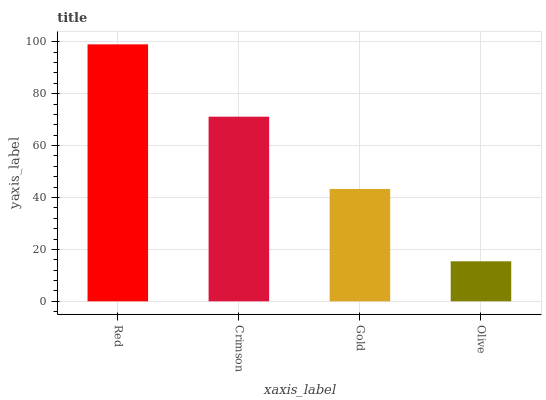Is Olive the minimum?
Answer yes or no. Yes. Is Red the maximum?
Answer yes or no. Yes. Is Crimson the minimum?
Answer yes or no. No. Is Crimson the maximum?
Answer yes or no. No. Is Red greater than Crimson?
Answer yes or no. Yes. Is Crimson less than Red?
Answer yes or no. Yes. Is Crimson greater than Red?
Answer yes or no. No. Is Red less than Crimson?
Answer yes or no. No. Is Crimson the high median?
Answer yes or no. Yes. Is Gold the low median?
Answer yes or no. Yes. Is Olive the high median?
Answer yes or no. No. Is Olive the low median?
Answer yes or no. No. 